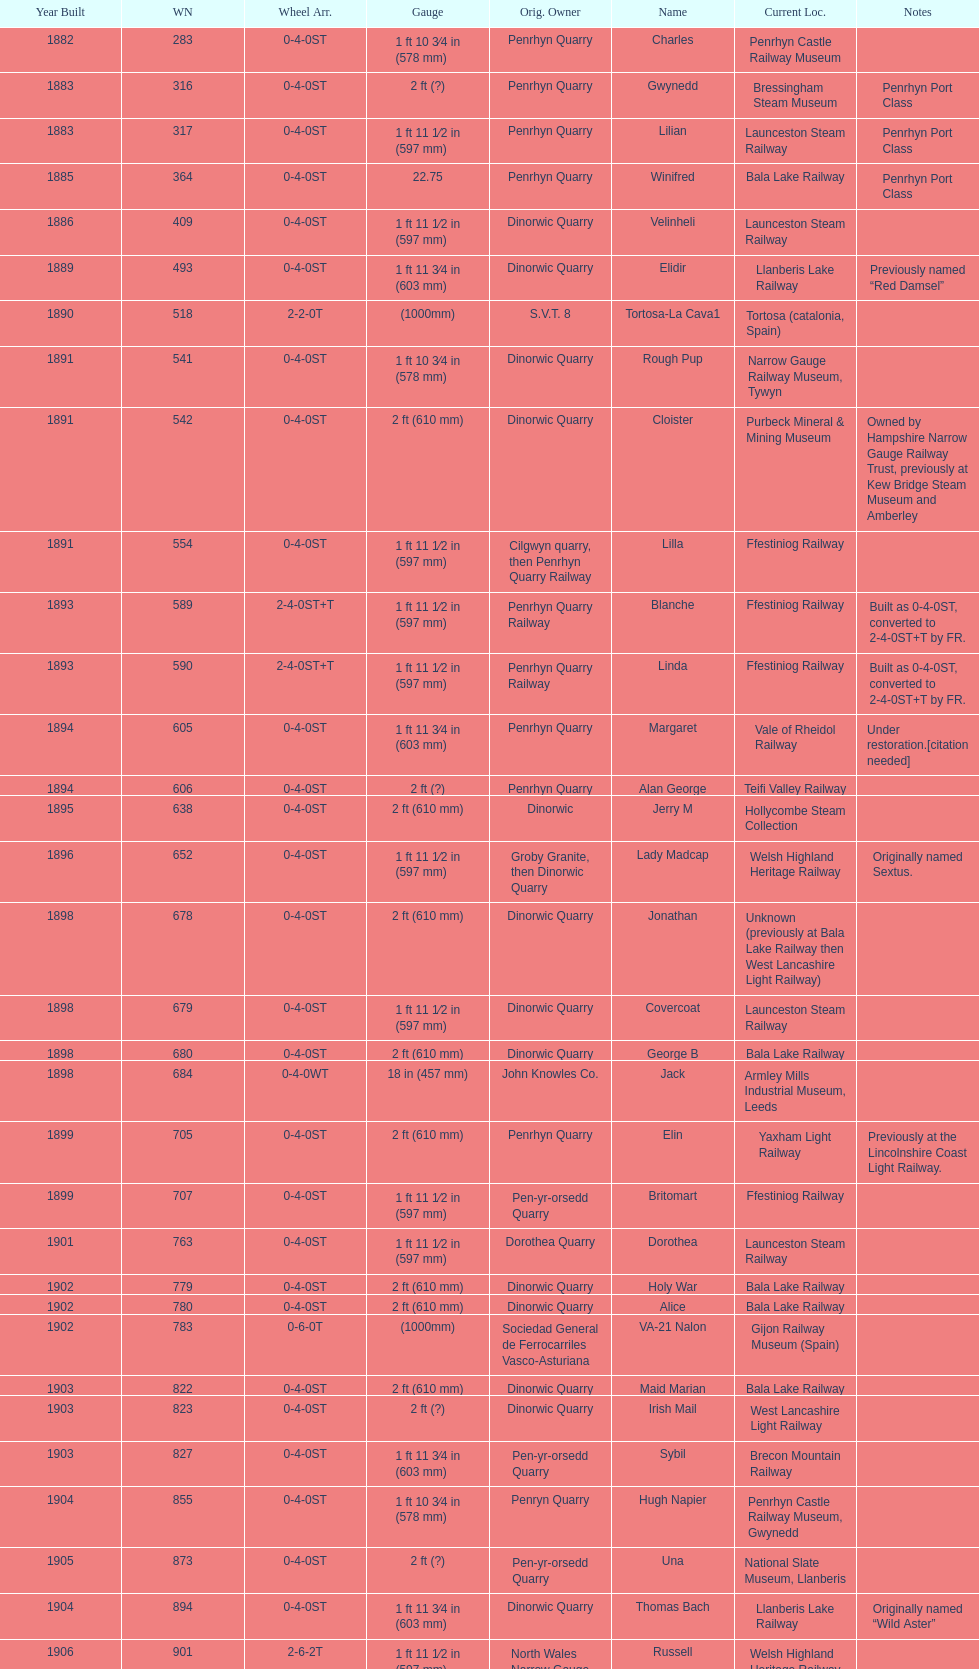How many steam locomotives are currently located at the bala lake railway? 364. 